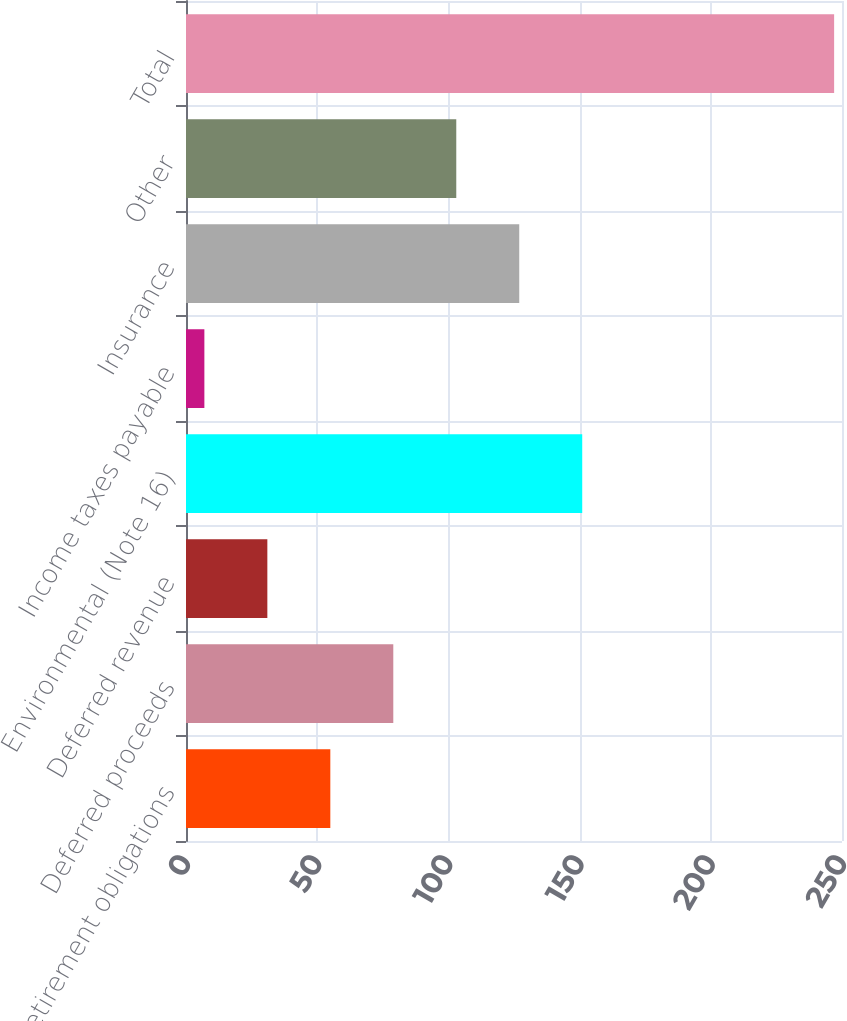Convert chart. <chart><loc_0><loc_0><loc_500><loc_500><bar_chart><fcel>Asset retirement obligations<fcel>Deferred proceeds<fcel>Deferred revenue<fcel>Environmental (Note 16)<fcel>Income taxes payable<fcel>Insurance<fcel>Other<fcel>Total<nl><fcel>55<fcel>79<fcel>31<fcel>151<fcel>7<fcel>127<fcel>103<fcel>247<nl></chart> 